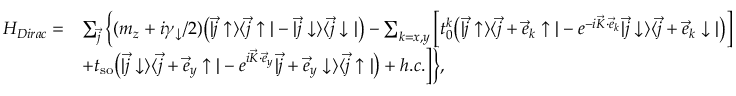<formula> <loc_0><loc_0><loc_500><loc_500>\begin{array} { r l } { H _ { D i r a c } = } & { \sum _ { \vec { j } } \Big \{ ( m _ { z } + i \gamma _ { \downarrow } / 2 ) \Big ( | \vec { j } \uparrow \rangle \langle \vec { j } \uparrow | - | \vec { j } \downarrow \rangle \langle \vec { j } \downarrow | \Big ) - \sum _ { k = x , y } \Big [ t _ { 0 } ^ { k } \Big ( | \vec { j } \uparrow \rangle \langle \vec { j } + \vec { e } _ { k } \uparrow | - e ^ { - i \vec { K } \cdot \vec { e } _ { k } } | \vec { j } \downarrow \rangle \langle \vec { j } + \vec { e } _ { k } \downarrow | \Big ) \Big ] } \\ & { + t _ { s o } \Big ( | \vec { j } \downarrow \rangle \langle \vec { j } + \vec { e } _ { y } \uparrow | - e ^ { i \vec { K } \cdot \vec { e } _ { y } } | \vec { j } + \vec { e } _ { y } \downarrow \rangle \langle \vec { j } \uparrow | \Big ) + h . c . \Big ] \Big \} , } \end{array}</formula> 